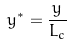Convert formula to latex. <formula><loc_0><loc_0><loc_500><loc_500>y ^ { * } = \frac { y } { L _ { c } }</formula> 